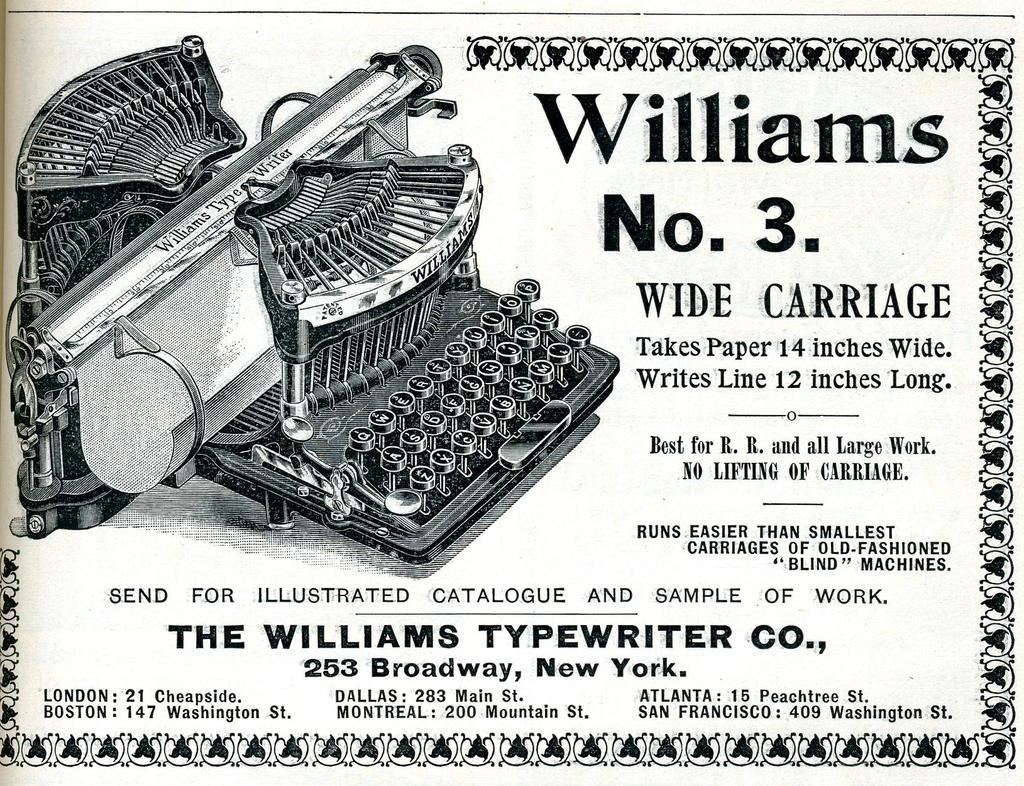<image>
Offer a succinct explanation of the picture presented. A Williams No.3 ad that is describing a typewriter company. 